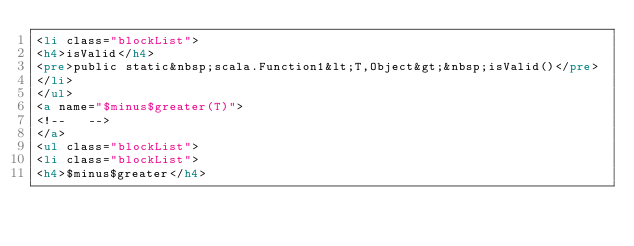Convert code to text. <code><loc_0><loc_0><loc_500><loc_500><_HTML_><li class="blockList">
<h4>isValid</h4>
<pre>public static&nbsp;scala.Function1&lt;T,Object&gt;&nbsp;isValid()</pre>
</li>
</ul>
<a name="$minus$greater(T)">
<!--   -->
</a>
<ul class="blockList">
<li class="blockList">
<h4>$minus$greater</h4></code> 